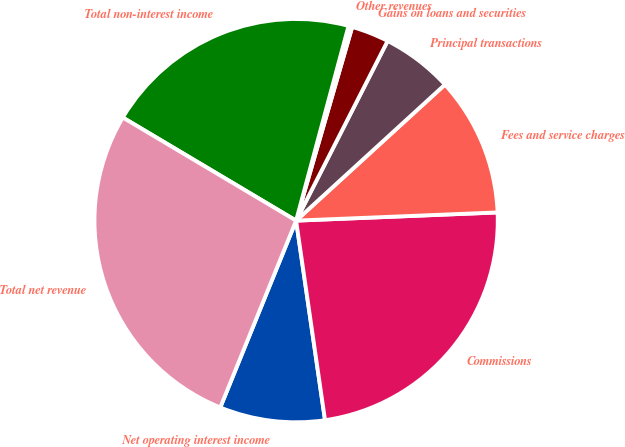Convert chart to OTSL. <chart><loc_0><loc_0><loc_500><loc_500><pie_chart><fcel>Net operating interest income<fcel>Commissions<fcel>Fees and service charges<fcel>Principal transactions<fcel>Gains on loans and securities<fcel>Other revenues<fcel>Total non-interest income<fcel>Total net revenue<nl><fcel>8.43%<fcel>23.36%<fcel>11.14%<fcel>5.72%<fcel>3.01%<fcel>0.3%<fcel>20.65%<fcel>27.41%<nl></chart> 